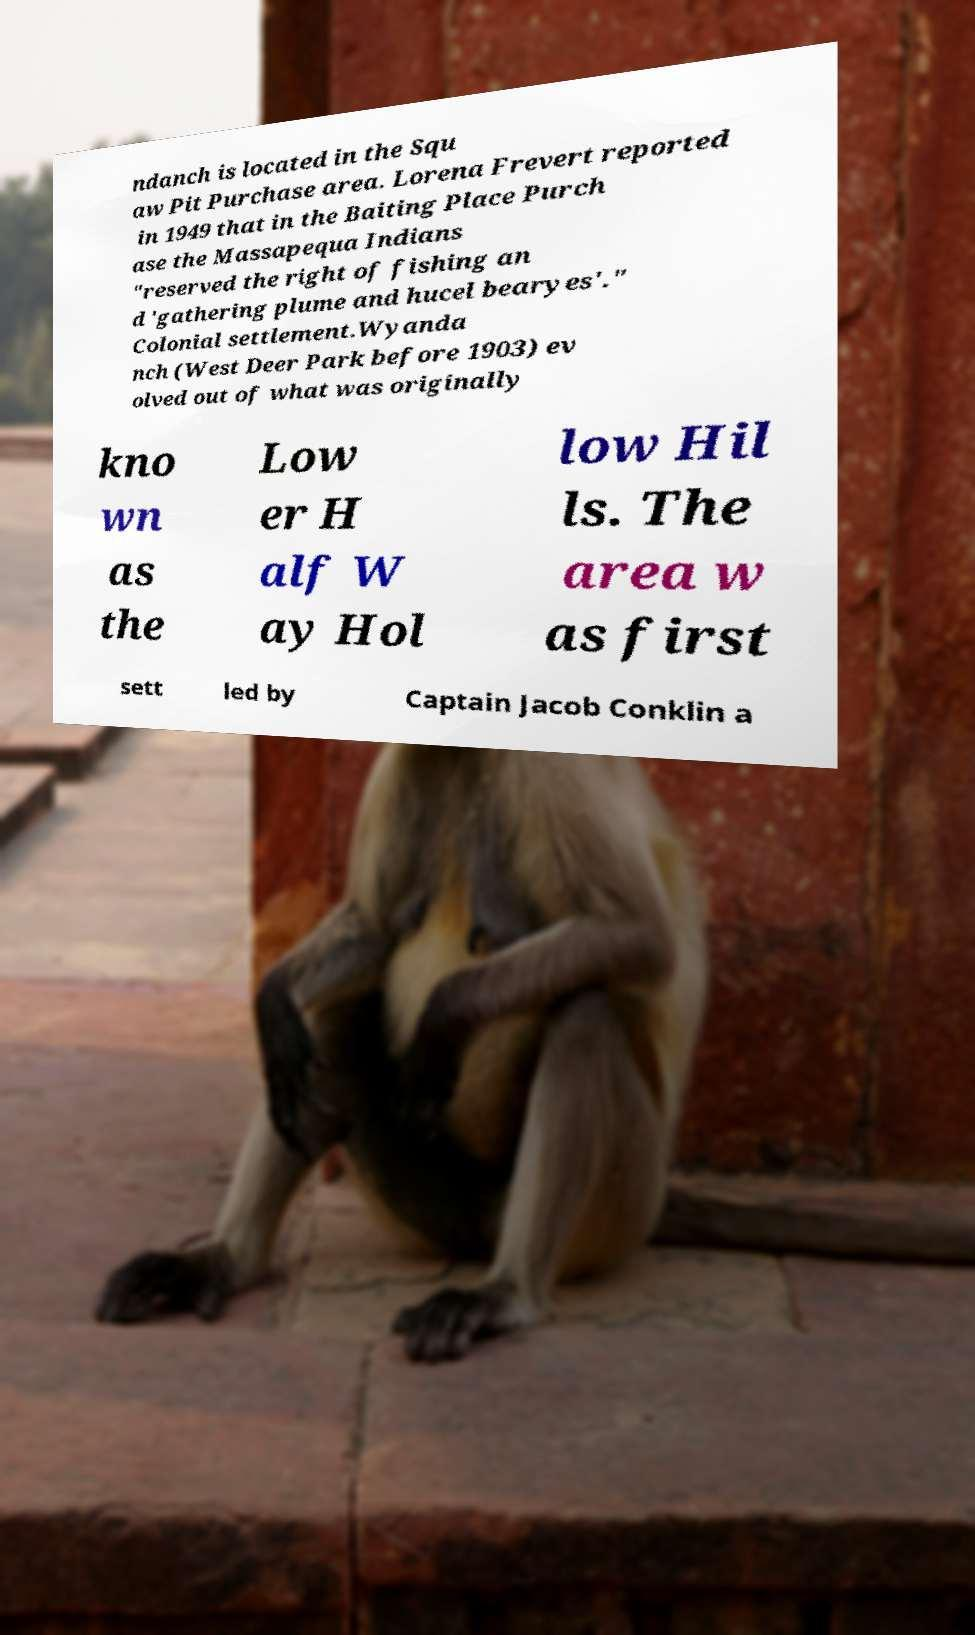Can you accurately transcribe the text from the provided image for me? ndanch is located in the Squ aw Pit Purchase area. Lorena Frevert reported in 1949 that in the Baiting Place Purch ase the Massapequa Indians "reserved the right of fishing an d 'gathering plume and hucel bearyes'." Colonial settlement.Wyanda nch (West Deer Park before 1903) ev olved out of what was originally kno wn as the Low er H alf W ay Hol low Hil ls. The area w as first sett led by Captain Jacob Conklin a 